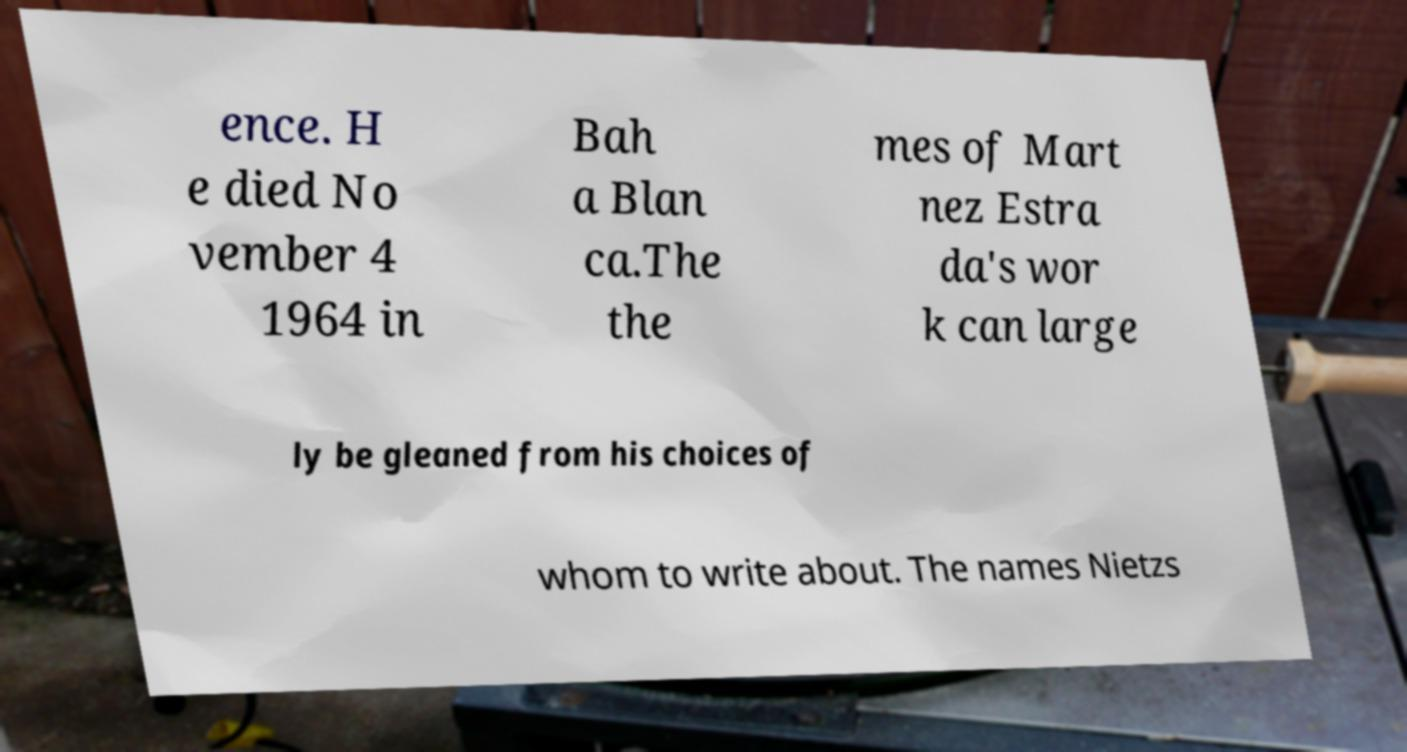Can you read and provide the text displayed in the image?This photo seems to have some interesting text. Can you extract and type it out for me? ence. H e died No vember 4 1964 in Bah a Blan ca.The the mes of Mart nez Estra da's wor k can large ly be gleaned from his choices of whom to write about. The names Nietzs 